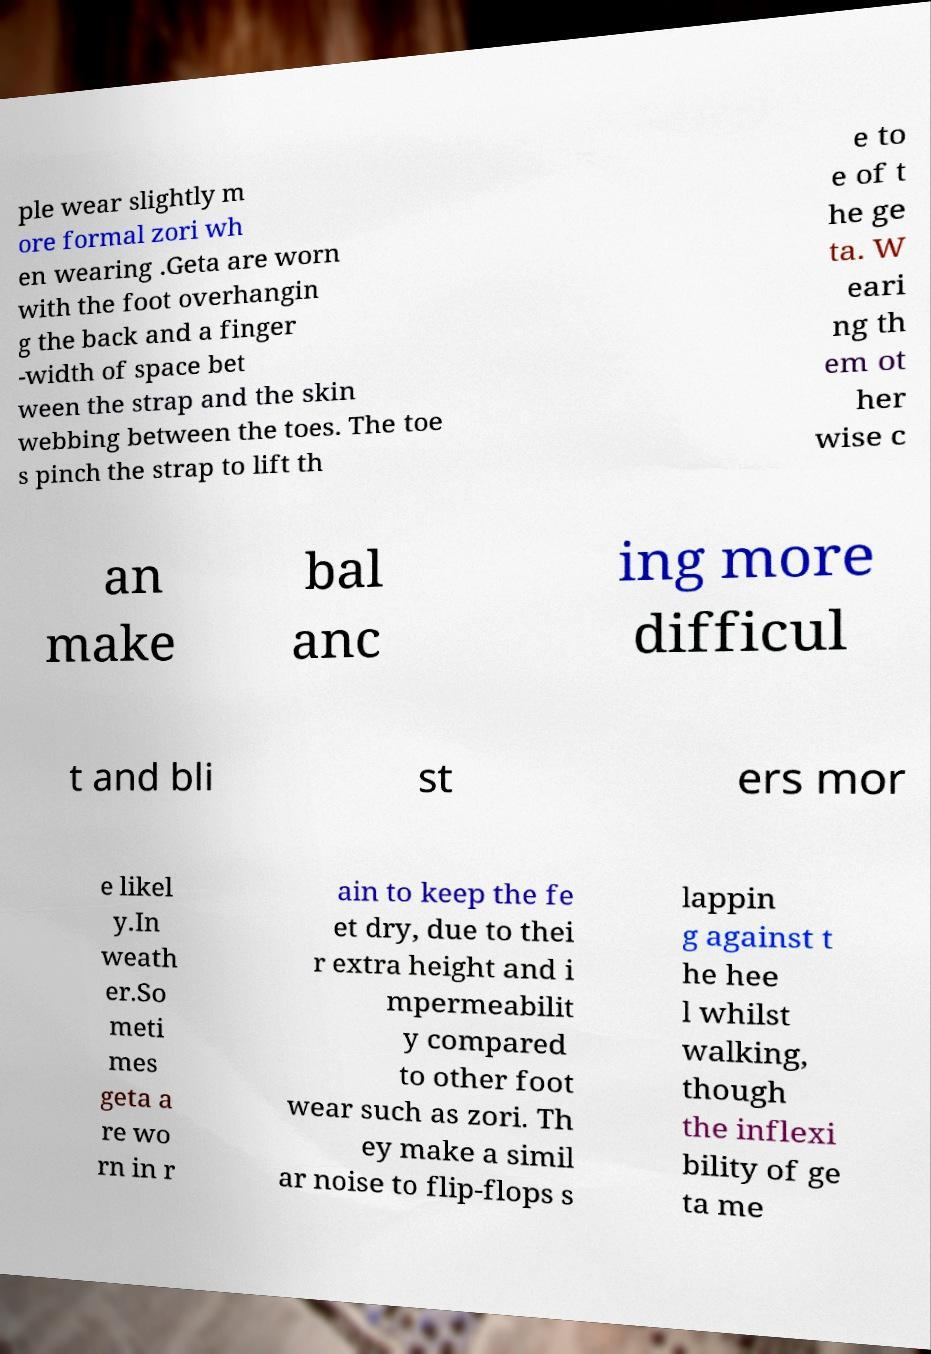What messages or text are displayed in this image? I need them in a readable, typed format. ple wear slightly m ore formal zori wh en wearing .Geta are worn with the foot overhangin g the back and a finger -width of space bet ween the strap and the skin webbing between the toes. The toe s pinch the strap to lift th e to e of t he ge ta. W eari ng th em ot her wise c an make bal anc ing more difficul t and bli st ers mor e likel y.In weath er.So meti mes geta a re wo rn in r ain to keep the fe et dry, due to thei r extra height and i mpermeabilit y compared to other foot wear such as zori. Th ey make a simil ar noise to flip-flops s lappin g against t he hee l whilst walking, though the inflexi bility of ge ta me 